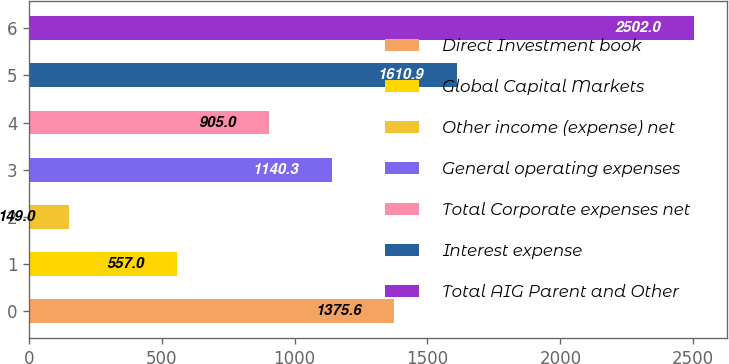Convert chart to OTSL. <chart><loc_0><loc_0><loc_500><loc_500><bar_chart><fcel>Direct Investment book<fcel>Global Capital Markets<fcel>Other income (expense) net<fcel>General operating expenses<fcel>Total Corporate expenses net<fcel>Interest expense<fcel>Total AIG Parent and Other<nl><fcel>1375.6<fcel>557<fcel>149<fcel>1140.3<fcel>905<fcel>1610.9<fcel>2502<nl></chart> 